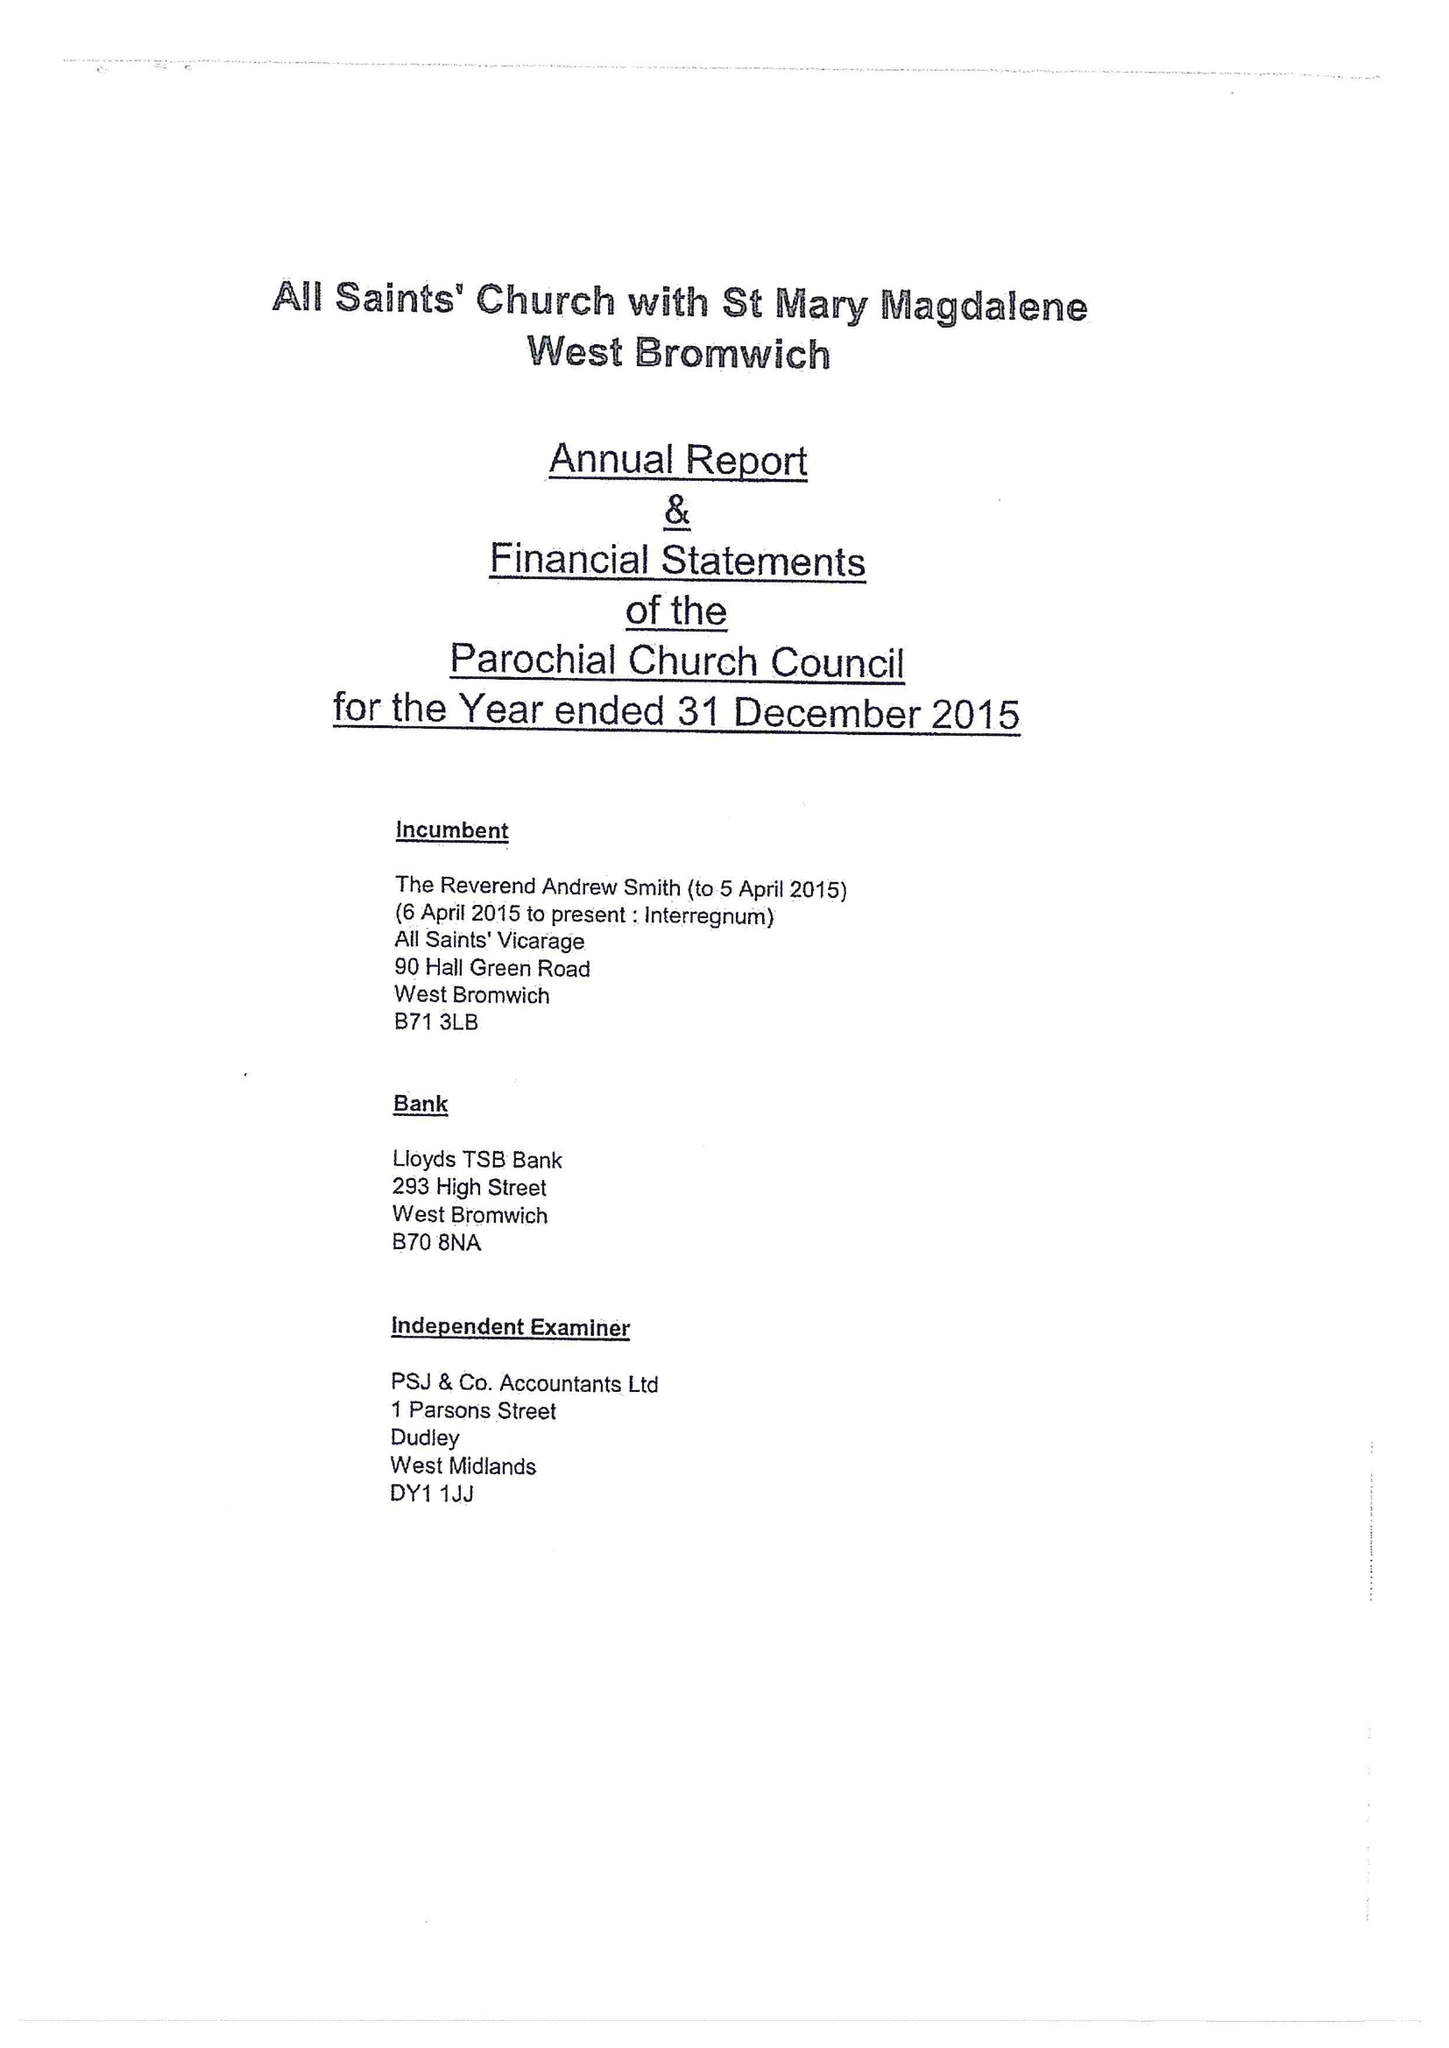What is the value for the address__street_line?
Answer the question using a single word or phrase. 38 PEAR TREE DRIVE 